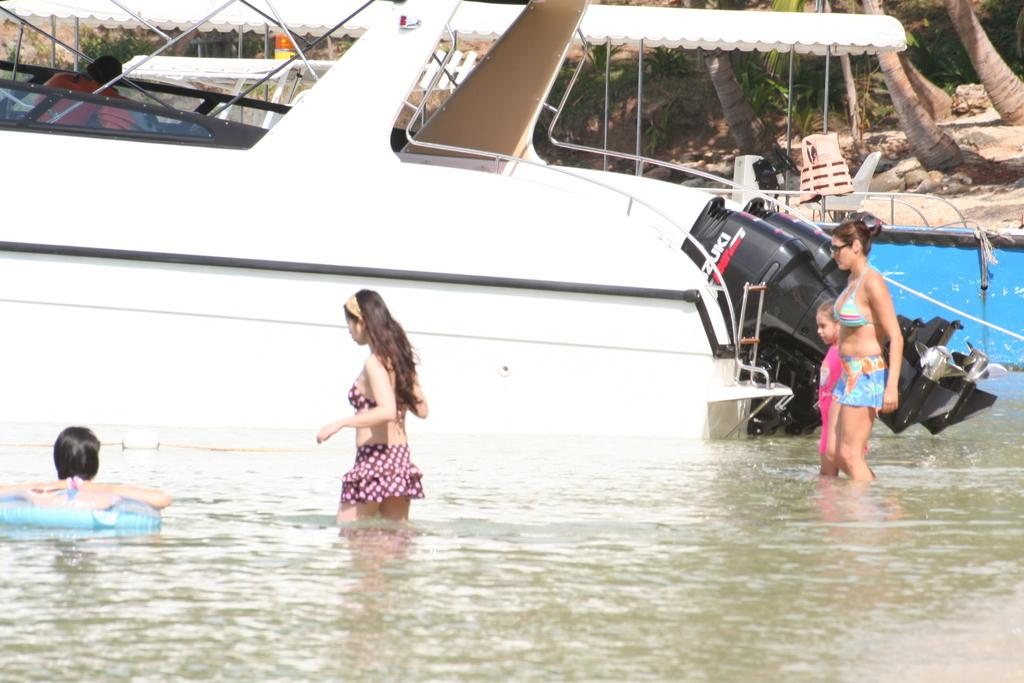What are the people in the image doing? The people in the image are in the water. What else can be seen in the image besides the people in the water? There is a boat in the image, and there is a person in the boat. What is visible in the background of the image? There are trees in the background of the image. What type of plantation can be seen in the image? There is no plantation present in the image. What is the texture of the water in the image? The texture of the water cannot be determined from the image alone, as it is a two-dimensional representation. 